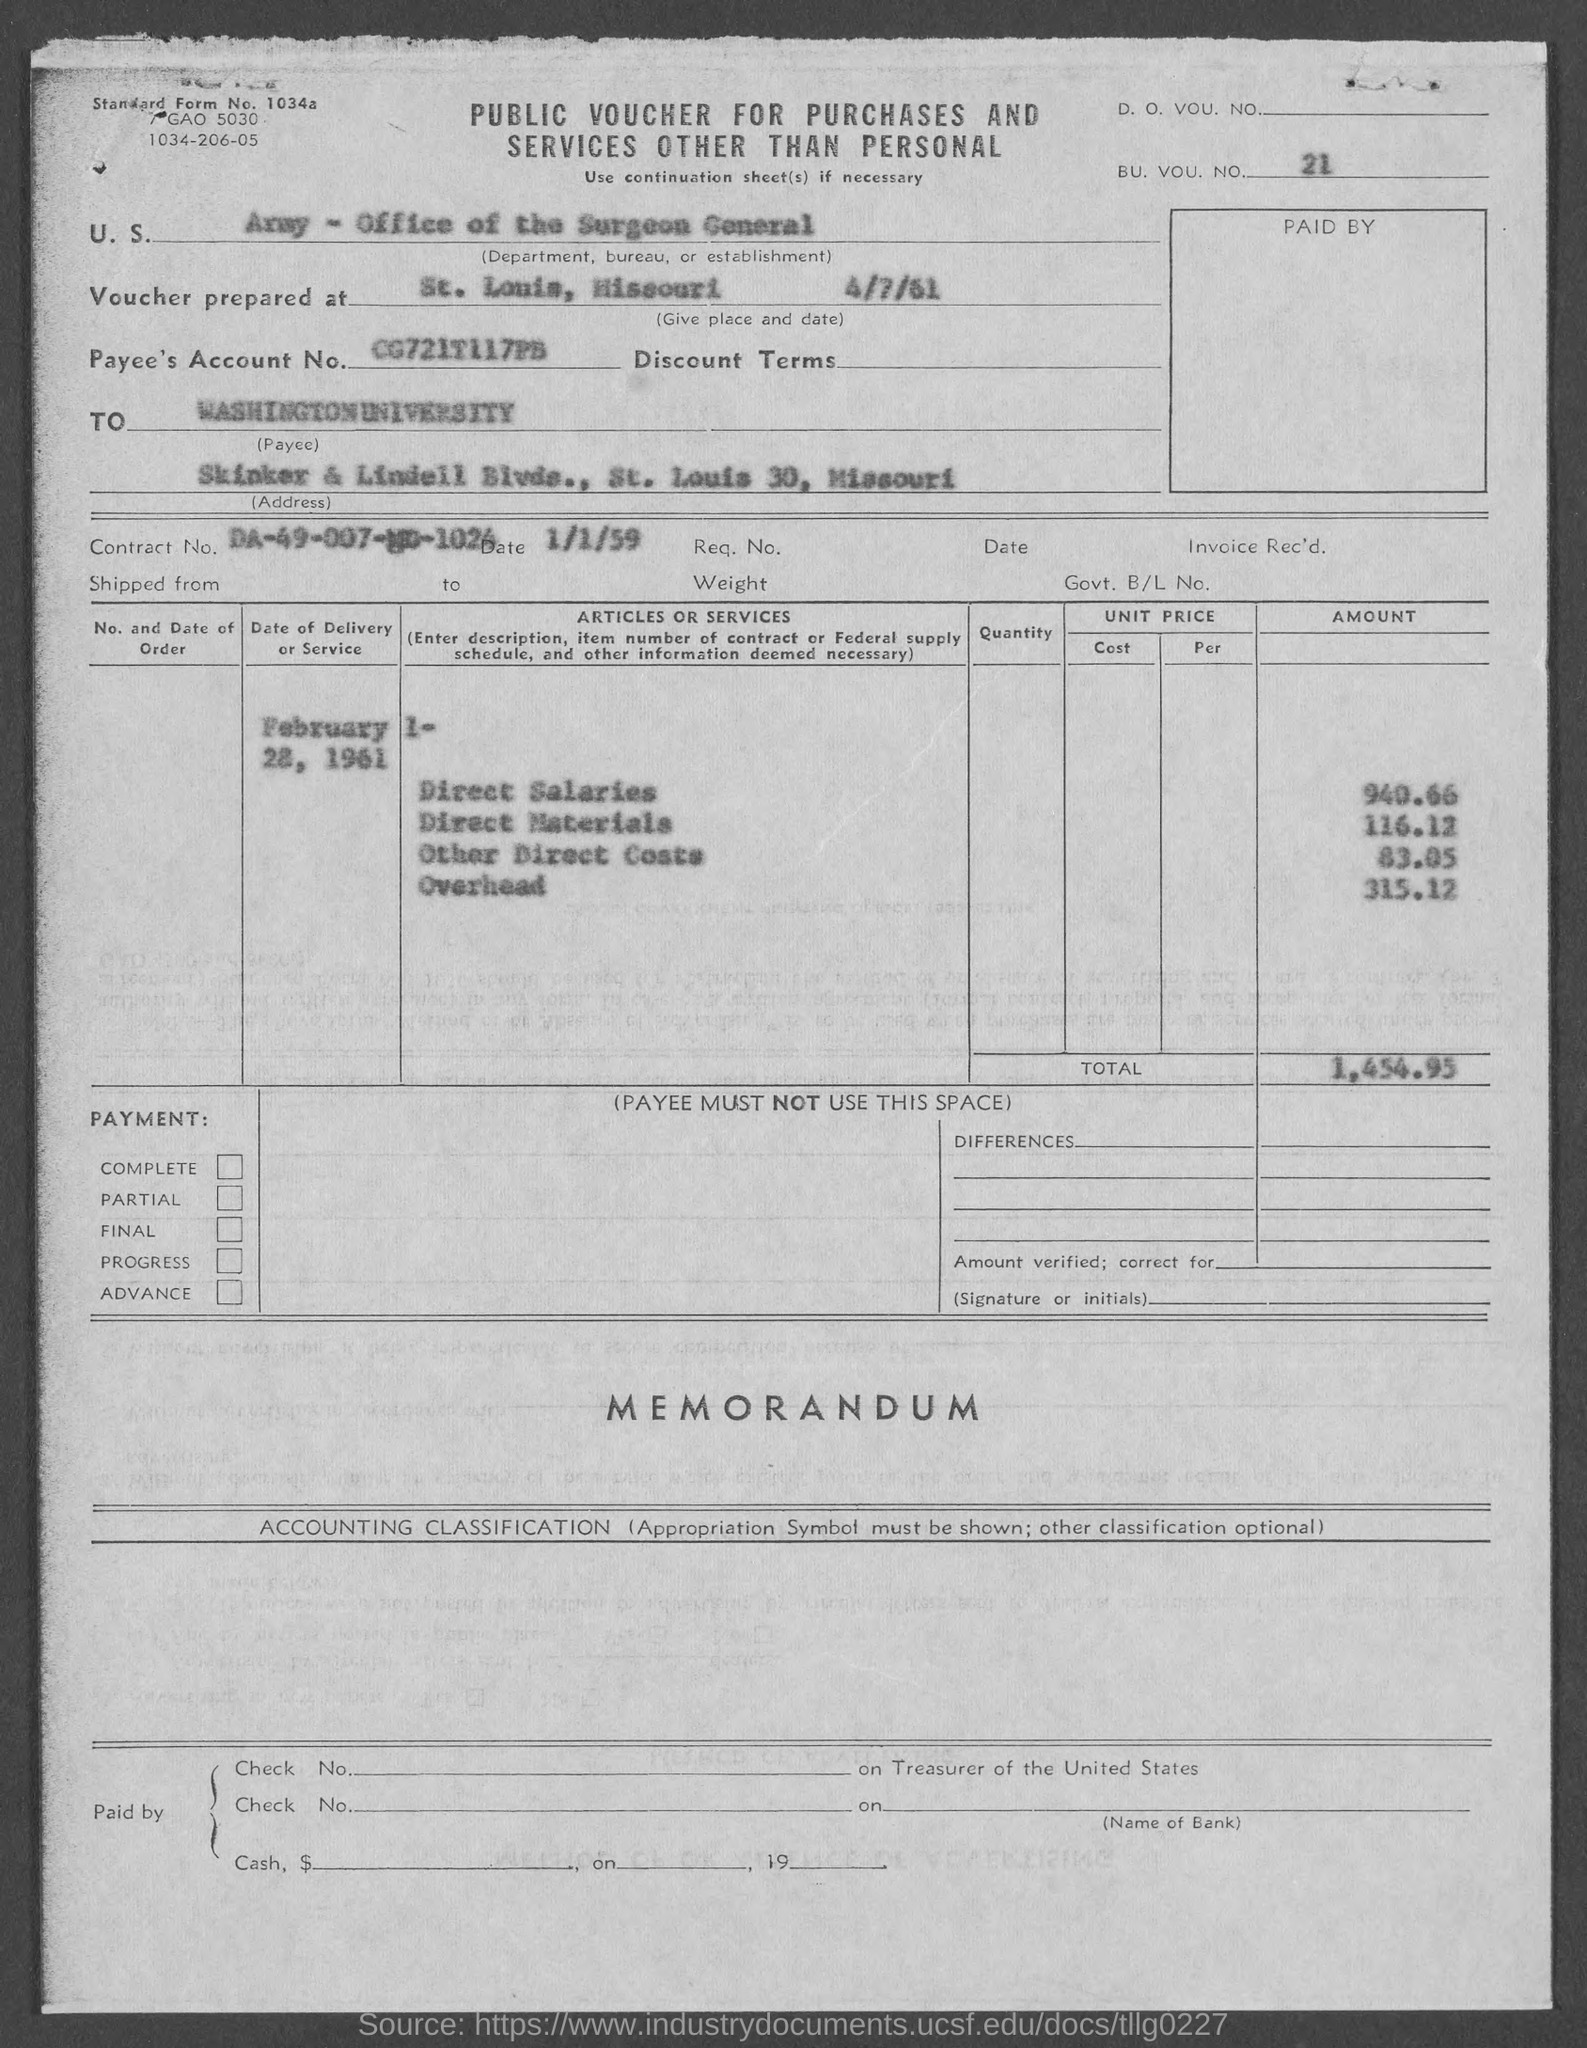Draw attention to some important aspects in this diagram. The contract number is DA-49-007-MD-1024. The total amount is 1,454.95. What is the BU. VOU. number?" is a question asking for the BU. VOU. number. 